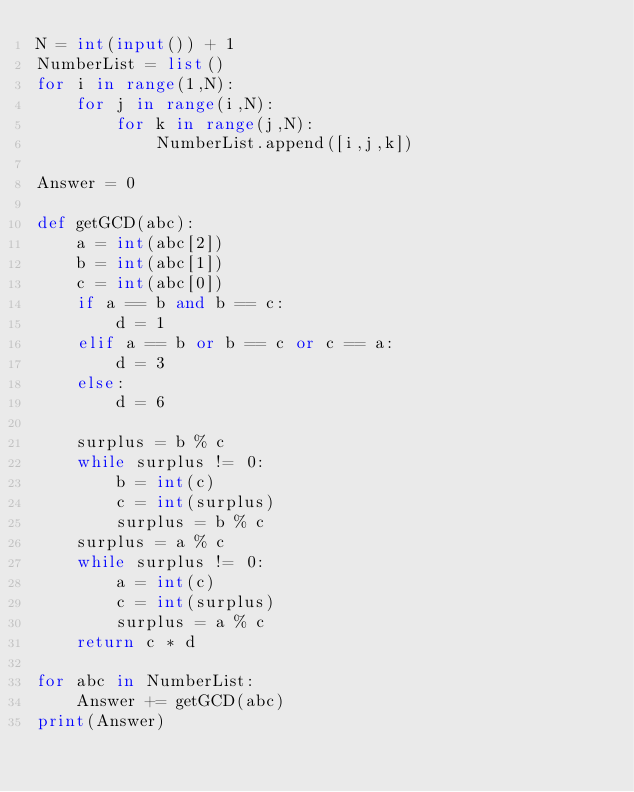Convert code to text. <code><loc_0><loc_0><loc_500><loc_500><_Python_>N = int(input()) + 1
NumberList = list()
for i in range(1,N):
    for j in range(i,N):
        for k in range(j,N):
            NumberList.append([i,j,k])

Answer = 0

def getGCD(abc):
    a = int(abc[2])
    b = int(abc[1])
    c = int(abc[0])
    if a == b and b == c:
        d = 1
    elif a == b or b == c or c == a:
        d = 3
    else:
        d = 6
        
    surplus = b % c
    while surplus != 0:
        b = int(c)
        c = int(surplus)
        surplus = b % c
    surplus = a % c
    while surplus != 0:
        a = int(c)
        c = int(surplus)
        surplus = a % c
    return c * d

for abc in NumberList:
    Answer += getGCD(abc)
print(Answer)
</code> 